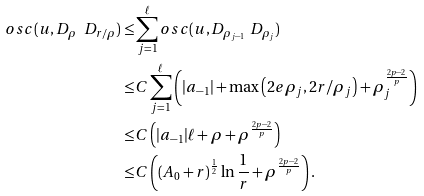<formula> <loc_0><loc_0><loc_500><loc_500>o s c ( u , D _ { \rho } \ D _ { r / \rho } ) \leq & \sum _ { j = 1 } ^ { \ell } o s c ( u , D _ { \rho _ { j - 1 } } \ D _ { \rho _ { j } } ) \\ \leq & C \sum _ { j = 1 } ^ { \ell } \left ( | a _ { - 1 } | + \max \left ( { 2 e \rho _ { j } } , 2 r / \rho _ { j } \right ) + \rho _ { j } ^ { \frac { 2 p - 2 } { p } } \right ) \\ \leq & C \left ( | a _ { - 1 } | \ell + \rho + \rho ^ { \frac { 2 p - 2 } { p } } \right ) \\ \leq & C \left ( ( A _ { 0 } + r ) ^ { \frac { 1 } { 2 } } \ln \frac { 1 } { r } + \rho ^ { \frac { 2 p - 2 } { p } } \right ) .</formula> 